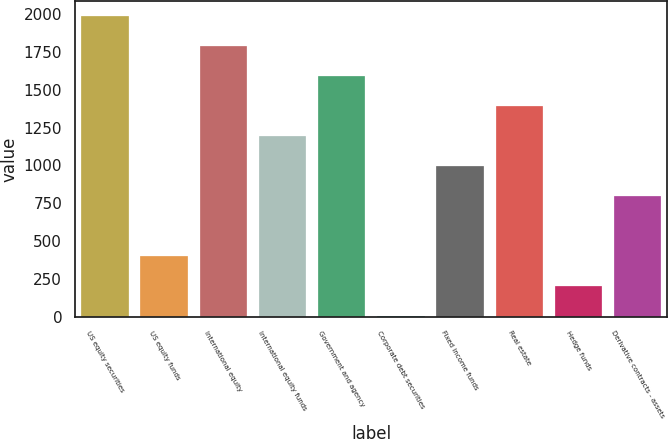Convert chart to OTSL. <chart><loc_0><loc_0><loc_500><loc_500><bar_chart><fcel>US equity securities<fcel>US equity funds<fcel>International equity<fcel>International equity funds<fcel>Government and agency<fcel>Corporate debt securities<fcel>Fixed income funds<fcel>Real estate<fcel>Hedge funds<fcel>Derivative contracts - assets<nl><fcel>1985<fcel>397.8<fcel>1786.6<fcel>1191.4<fcel>1588.2<fcel>1<fcel>993<fcel>1389.8<fcel>199.4<fcel>794.6<nl></chart> 